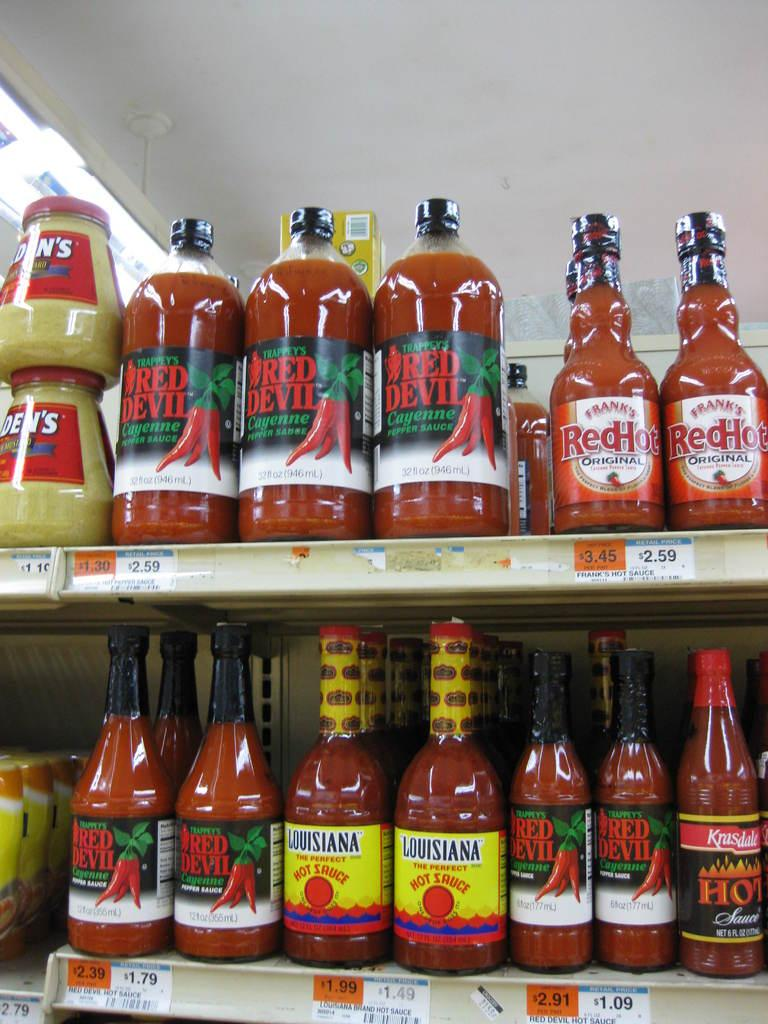<image>
Share a concise interpretation of the image provided. Bottles of Red Devil Cayenne Pepper Sauce line the shelves. 